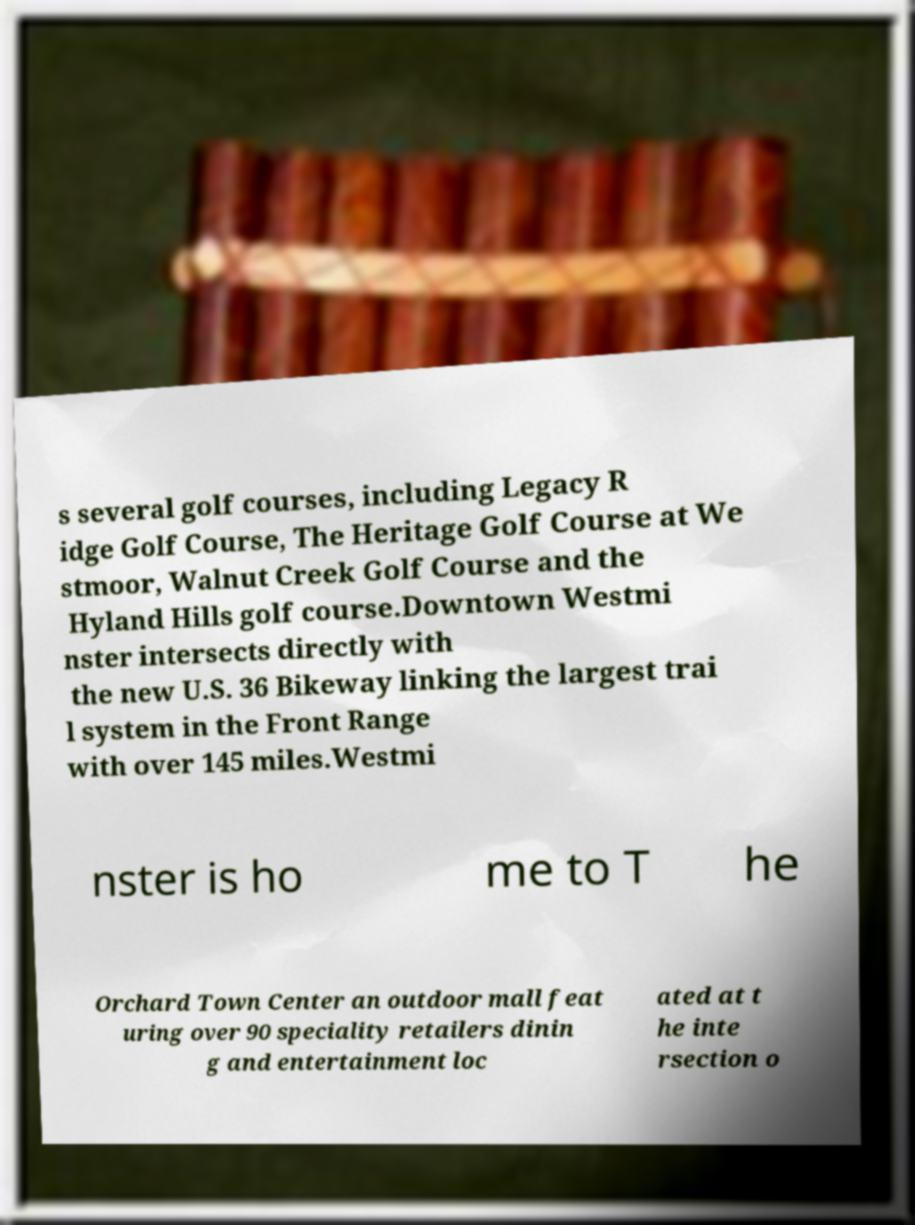Can you read and provide the text displayed in the image?This photo seems to have some interesting text. Can you extract and type it out for me? s several golf courses, including Legacy R idge Golf Course, The Heritage Golf Course at We stmoor, Walnut Creek Golf Course and the Hyland Hills golf course.Downtown Westmi nster intersects directly with the new U.S. 36 Bikeway linking the largest trai l system in the Front Range with over 145 miles.Westmi nster is ho me to T he Orchard Town Center an outdoor mall feat uring over 90 speciality retailers dinin g and entertainment loc ated at t he inte rsection o 